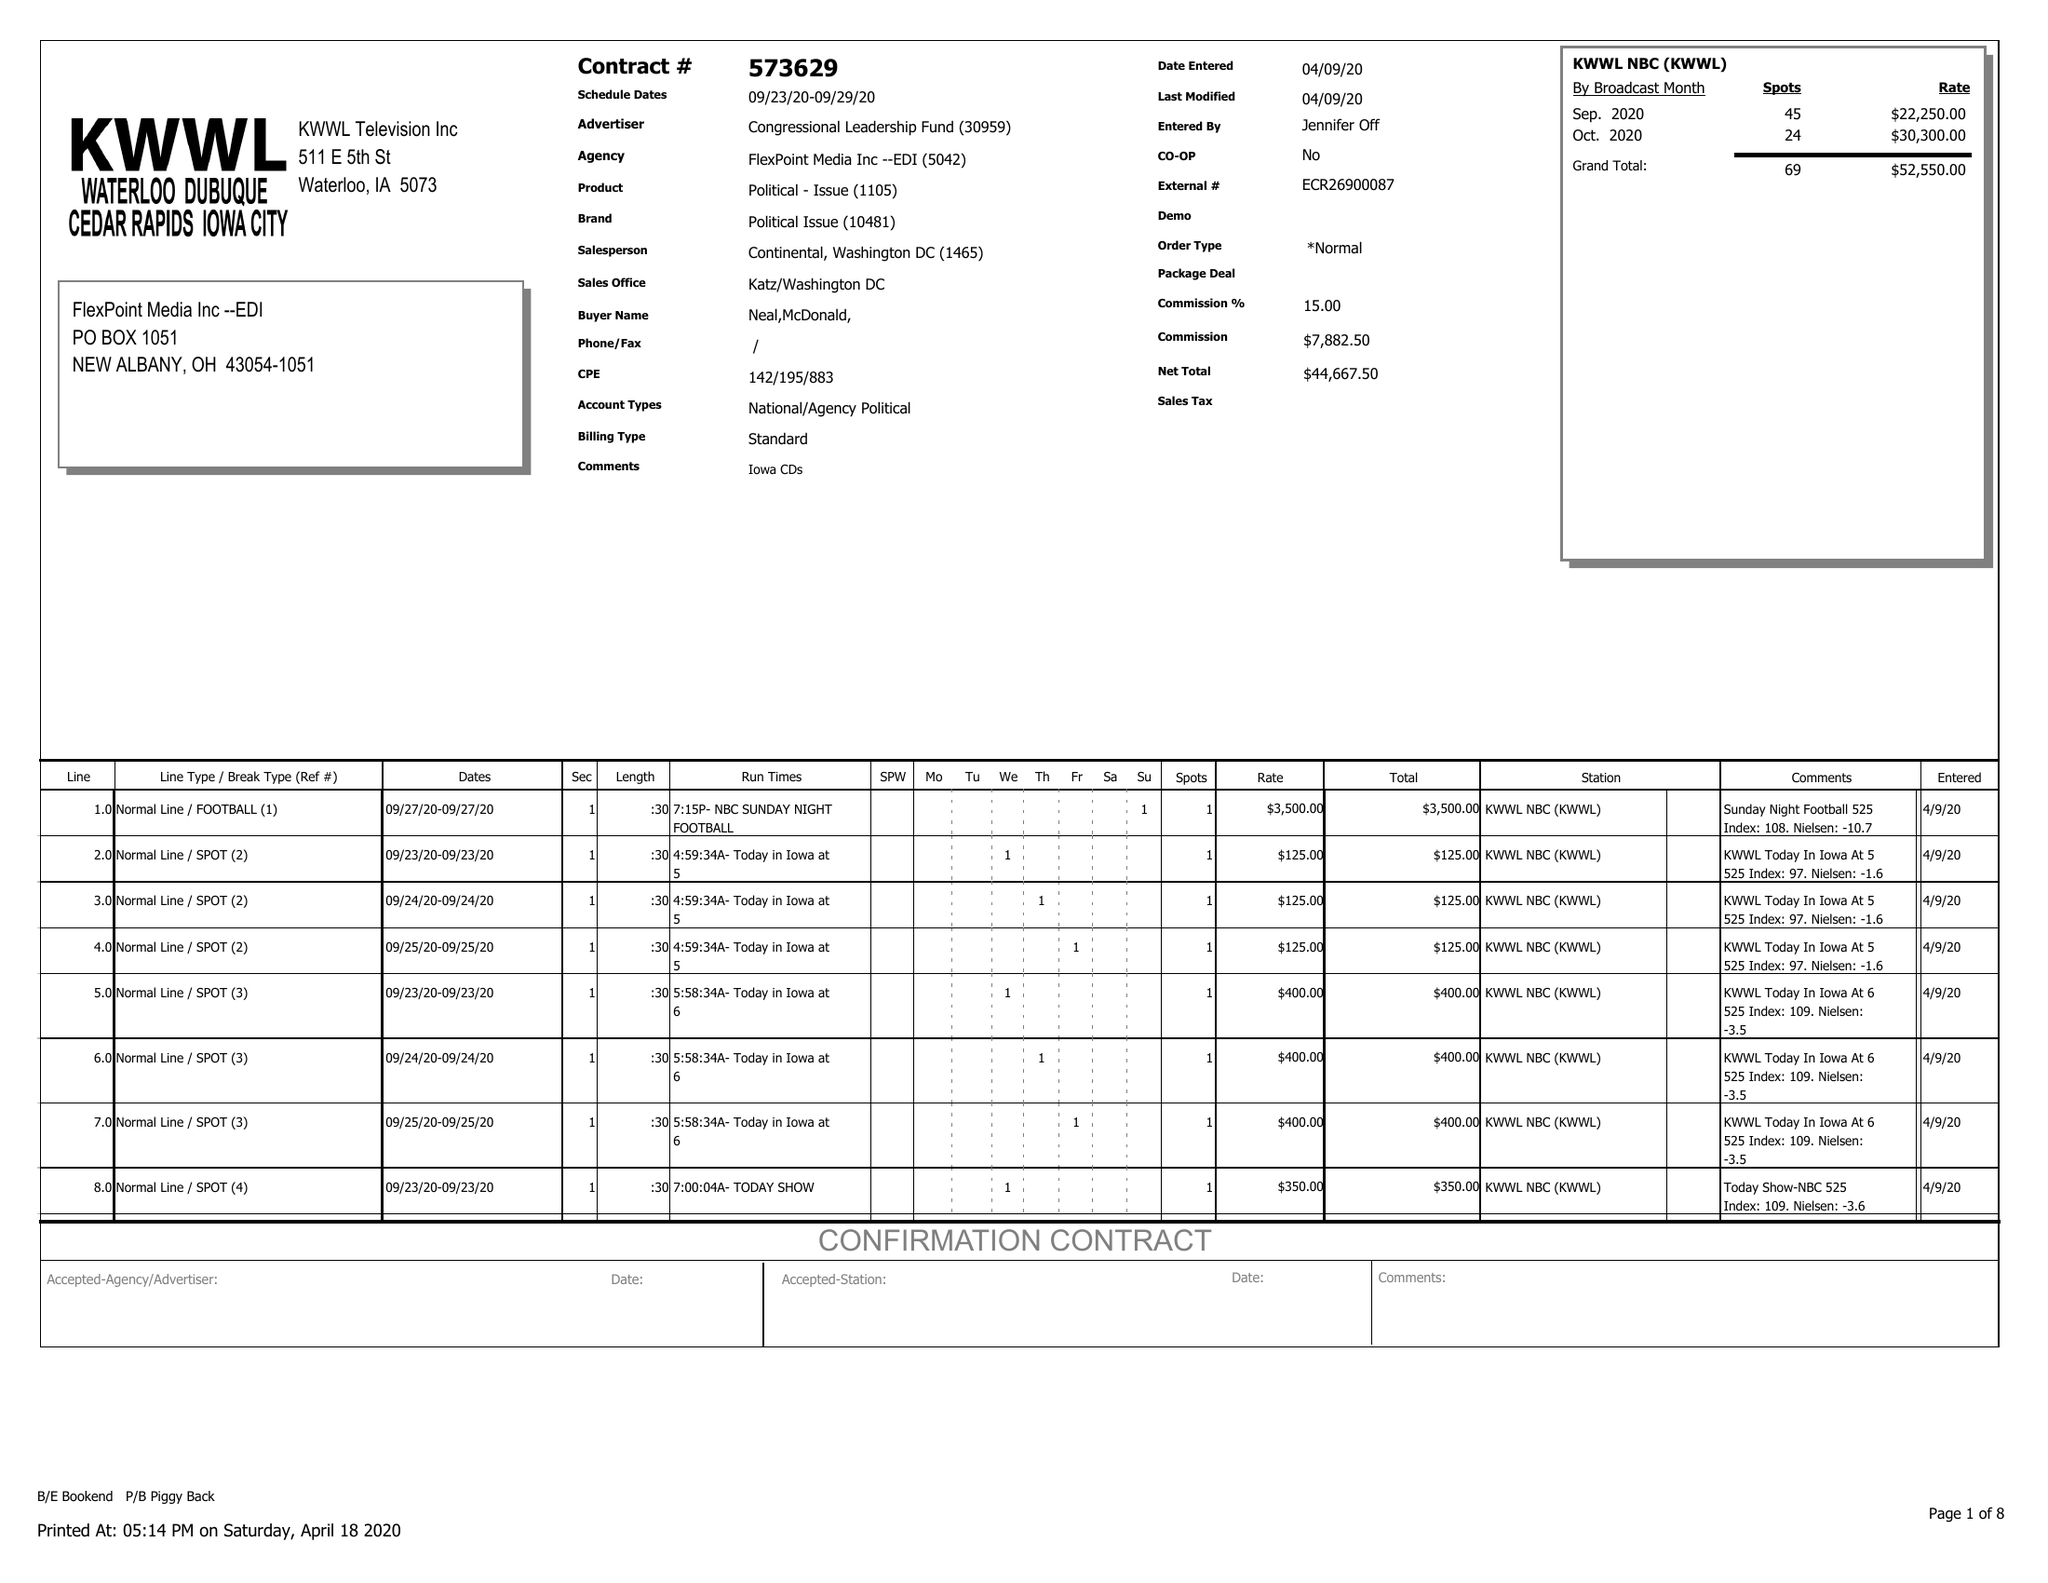What is the value for the flight_from?
Answer the question using a single word or phrase. 09/23/20 